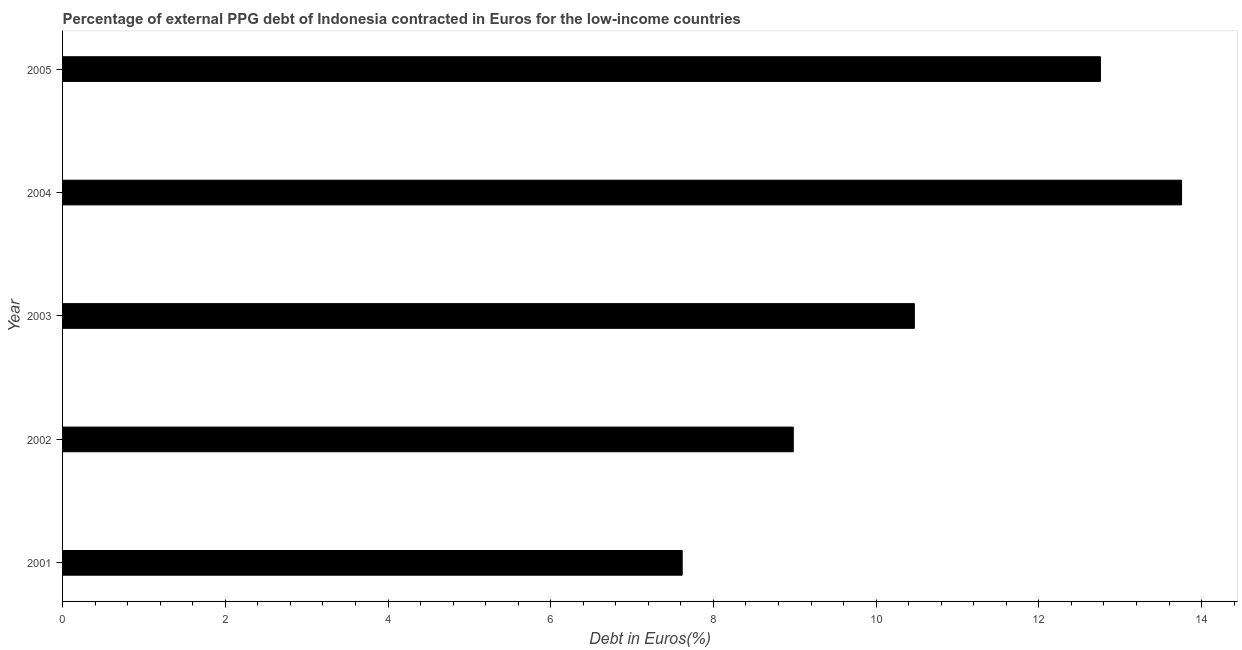Does the graph contain grids?
Your response must be concise. No. What is the title of the graph?
Give a very brief answer. Percentage of external PPG debt of Indonesia contracted in Euros for the low-income countries. What is the label or title of the X-axis?
Offer a very short reply. Debt in Euros(%). What is the currency composition of ppg debt in 2004?
Ensure brevity in your answer.  13.75. Across all years, what is the maximum currency composition of ppg debt?
Give a very brief answer. 13.75. Across all years, what is the minimum currency composition of ppg debt?
Your answer should be very brief. 7.62. In which year was the currency composition of ppg debt maximum?
Offer a terse response. 2004. What is the sum of the currency composition of ppg debt?
Your response must be concise. 53.58. What is the difference between the currency composition of ppg debt in 2001 and 2004?
Offer a very short reply. -6.14. What is the average currency composition of ppg debt per year?
Offer a terse response. 10.72. What is the median currency composition of ppg debt?
Ensure brevity in your answer.  10.47. In how many years, is the currency composition of ppg debt greater than 11.6 %?
Offer a terse response. 2. Do a majority of the years between 2003 and 2005 (inclusive) have currency composition of ppg debt greater than 12 %?
Offer a very short reply. Yes. What is the ratio of the currency composition of ppg debt in 2002 to that in 2005?
Your answer should be compact. 0.7. Is the currency composition of ppg debt in 2002 less than that in 2004?
Provide a short and direct response. Yes. Is the difference between the currency composition of ppg debt in 2002 and 2004 greater than the difference between any two years?
Offer a very short reply. No. What is the difference between the highest and the lowest currency composition of ppg debt?
Offer a very short reply. 6.14. How many bars are there?
Make the answer very short. 5. Are all the bars in the graph horizontal?
Offer a terse response. Yes. What is the difference between two consecutive major ticks on the X-axis?
Offer a very short reply. 2. What is the Debt in Euros(%) in 2001?
Provide a succinct answer. 7.62. What is the Debt in Euros(%) in 2002?
Offer a very short reply. 8.98. What is the Debt in Euros(%) in 2003?
Provide a short and direct response. 10.47. What is the Debt in Euros(%) of 2004?
Provide a succinct answer. 13.75. What is the Debt in Euros(%) of 2005?
Your answer should be very brief. 12.76. What is the difference between the Debt in Euros(%) in 2001 and 2002?
Your response must be concise. -1.37. What is the difference between the Debt in Euros(%) in 2001 and 2003?
Your response must be concise. -2.85. What is the difference between the Debt in Euros(%) in 2001 and 2004?
Your response must be concise. -6.14. What is the difference between the Debt in Euros(%) in 2001 and 2005?
Provide a succinct answer. -5.14. What is the difference between the Debt in Euros(%) in 2002 and 2003?
Offer a terse response. -1.49. What is the difference between the Debt in Euros(%) in 2002 and 2004?
Give a very brief answer. -4.77. What is the difference between the Debt in Euros(%) in 2002 and 2005?
Give a very brief answer. -3.78. What is the difference between the Debt in Euros(%) in 2003 and 2004?
Make the answer very short. -3.28. What is the difference between the Debt in Euros(%) in 2003 and 2005?
Your answer should be compact. -2.29. What is the ratio of the Debt in Euros(%) in 2001 to that in 2002?
Offer a terse response. 0.85. What is the ratio of the Debt in Euros(%) in 2001 to that in 2003?
Your answer should be very brief. 0.73. What is the ratio of the Debt in Euros(%) in 2001 to that in 2004?
Your answer should be compact. 0.55. What is the ratio of the Debt in Euros(%) in 2001 to that in 2005?
Offer a terse response. 0.6. What is the ratio of the Debt in Euros(%) in 2002 to that in 2003?
Give a very brief answer. 0.86. What is the ratio of the Debt in Euros(%) in 2002 to that in 2004?
Give a very brief answer. 0.65. What is the ratio of the Debt in Euros(%) in 2002 to that in 2005?
Ensure brevity in your answer.  0.7. What is the ratio of the Debt in Euros(%) in 2003 to that in 2004?
Provide a short and direct response. 0.76. What is the ratio of the Debt in Euros(%) in 2003 to that in 2005?
Give a very brief answer. 0.82. What is the ratio of the Debt in Euros(%) in 2004 to that in 2005?
Make the answer very short. 1.08. 